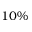Convert formula to latex. <formula><loc_0><loc_0><loc_500><loc_500>1 0 \%</formula> 